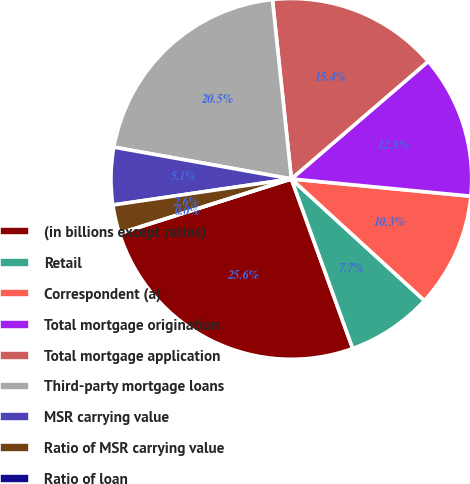Convert chart to OTSL. <chart><loc_0><loc_0><loc_500><loc_500><pie_chart><fcel>(in billions except ratios)<fcel>Retail<fcel>Correspondent (a)<fcel>Total mortgage origination<fcel>Total mortgage application<fcel>Third-party mortgage loans<fcel>MSR carrying value<fcel>Ratio of MSR carrying value<fcel>Ratio of loan<nl><fcel>25.64%<fcel>7.69%<fcel>10.26%<fcel>12.82%<fcel>15.38%<fcel>20.51%<fcel>5.13%<fcel>2.57%<fcel>0.0%<nl></chart> 